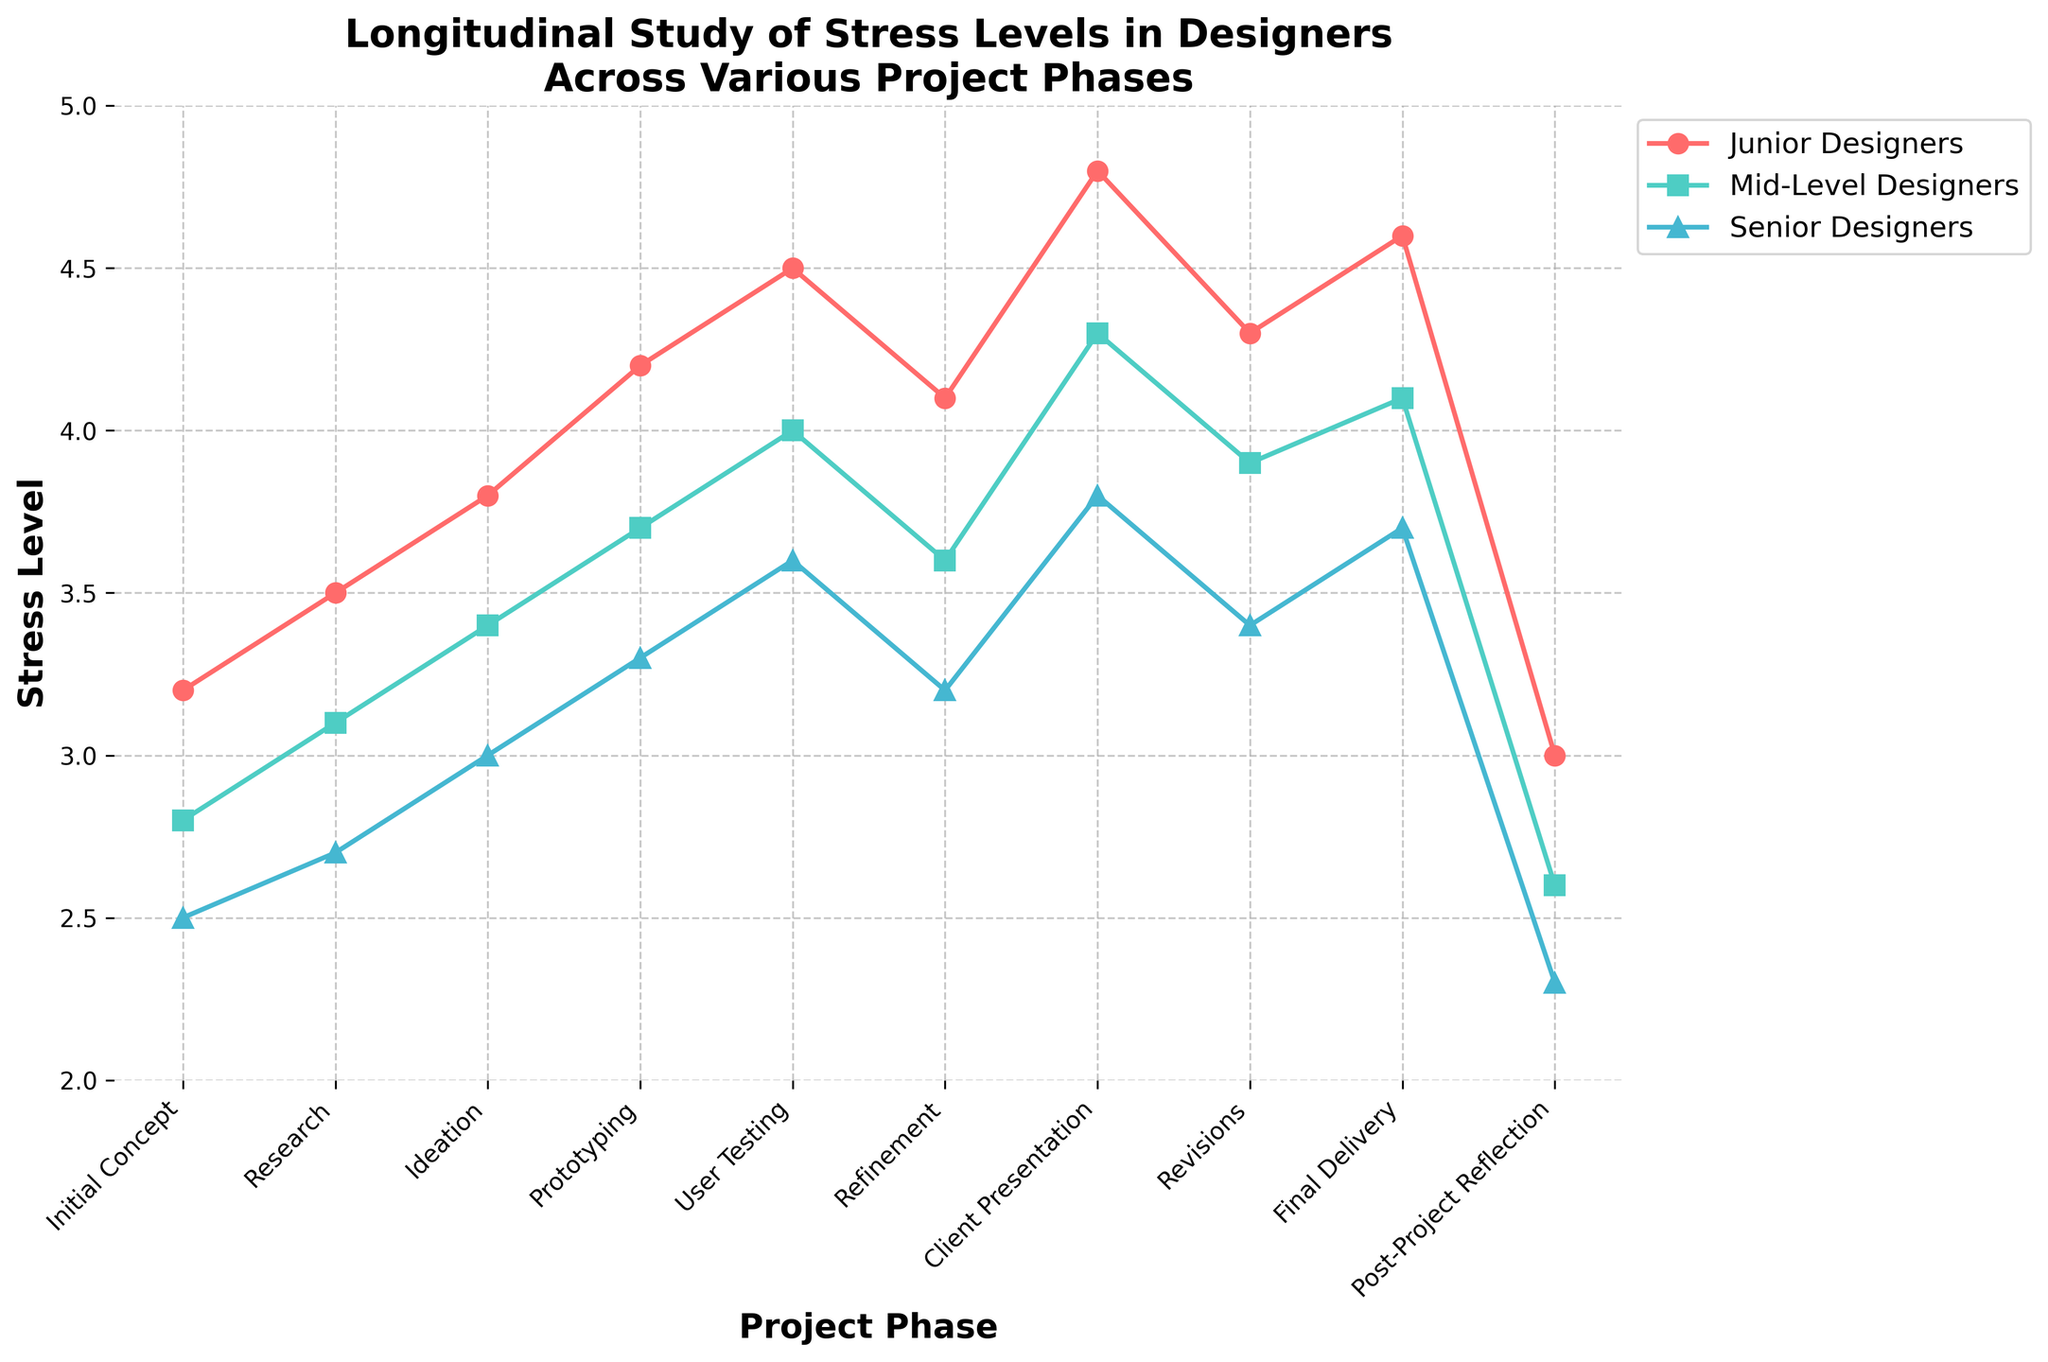What is the highest stress level reported by senior designers during any project phase? To find the highest stress level for senior designers, look at the blue line representing senior designers across all project phases. The peak occurs at "Client Presentation" with a stress level of 3.8.
Answer: 3.8 During which project phase do junior designers experience the lowest stress level? Examine the red line representing junior designers across all phases. The lowest point is at "Post-Project Reflection" with a stress level of 3.0.
Answer: Post-Project Reflection How does the stress level of mid-level designers during the “Ideation” phase compare to that of junior designers? Check the points on the green and red lines at "Ideation." The stress level for mid-level designers is 3.4, whereas for junior designers it is 3.8. So, mid-level designers experience lower stress.
Answer: Lower What is the average stress level of senior designers during the entire project timeline? Sum the stress levels of senior designers across all phases: 2.5 + 2.7 + 3.0 + 3.3 + 3.6 + 3.2 + 3.8 + 3.4 + 3.7 + 2.3 = 31.5. Divide by the number of phases, 31.5/10 = 3.15.
Answer: 3.15 Which project phase shows the largest difference in stress levels between junior and senior designers? Calculate the difference for each phase: 3.2-2.5, 3.5-2.7, 3.8-3.0, 4.2-3.3, 4.5-3.6, 4.1-3.2, 4.8-3.8, 4.3-3.4, 4.6-3.7, 3.0-2.3. The largest difference is at "Client Presentation" with a difference of 1.0.
Answer: Client Presentation During which two consecutive project phases is the increase in stress level for mid-level designers the highest? Calculate the increase between each consecutive phase for mid-level designers: 3.1-2.8, 3.4-3.1, 3.7-3.4, 4.0-3.7, 3.6-4.0, 4.3-3.6, 3.9-4.3, 4.1-3.9, 2.6-4.1. The highest increase is between "User Testing" and "Refinement" (4.0-3.6 = 0.4)
Answer: User Testing to Refinement 